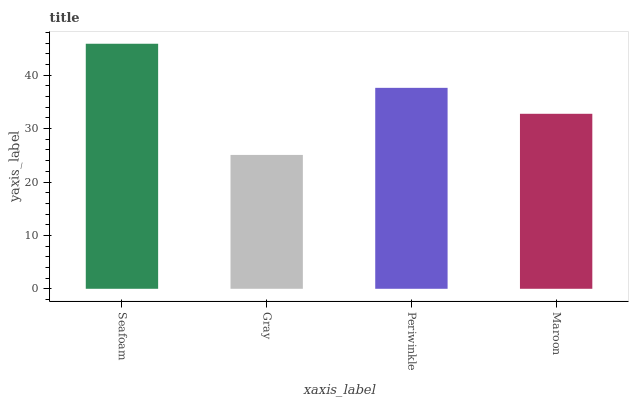Is Gray the minimum?
Answer yes or no. Yes. Is Seafoam the maximum?
Answer yes or no. Yes. Is Periwinkle the minimum?
Answer yes or no. No. Is Periwinkle the maximum?
Answer yes or no. No. Is Periwinkle greater than Gray?
Answer yes or no. Yes. Is Gray less than Periwinkle?
Answer yes or no. Yes. Is Gray greater than Periwinkle?
Answer yes or no. No. Is Periwinkle less than Gray?
Answer yes or no. No. Is Periwinkle the high median?
Answer yes or no. Yes. Is Maroon the low median?
Answer yes or no. Yes. Is Seafoam the high median?
Answer yes or no. No. Is Seafoam the low median?
Answer yes or no. No. 